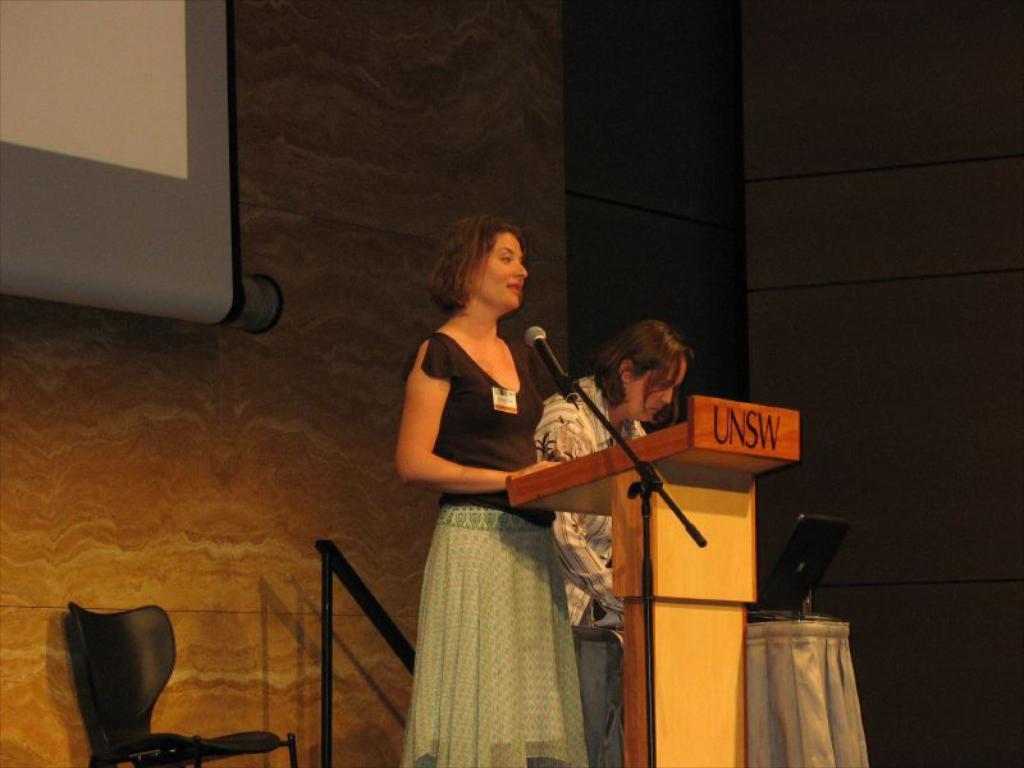Can you describe this image briefly? In this picture we can see woman standing in front of the podium and talking to the mic and beside to her one more person also standing and in background we can see wall, screen, chair, pole. 